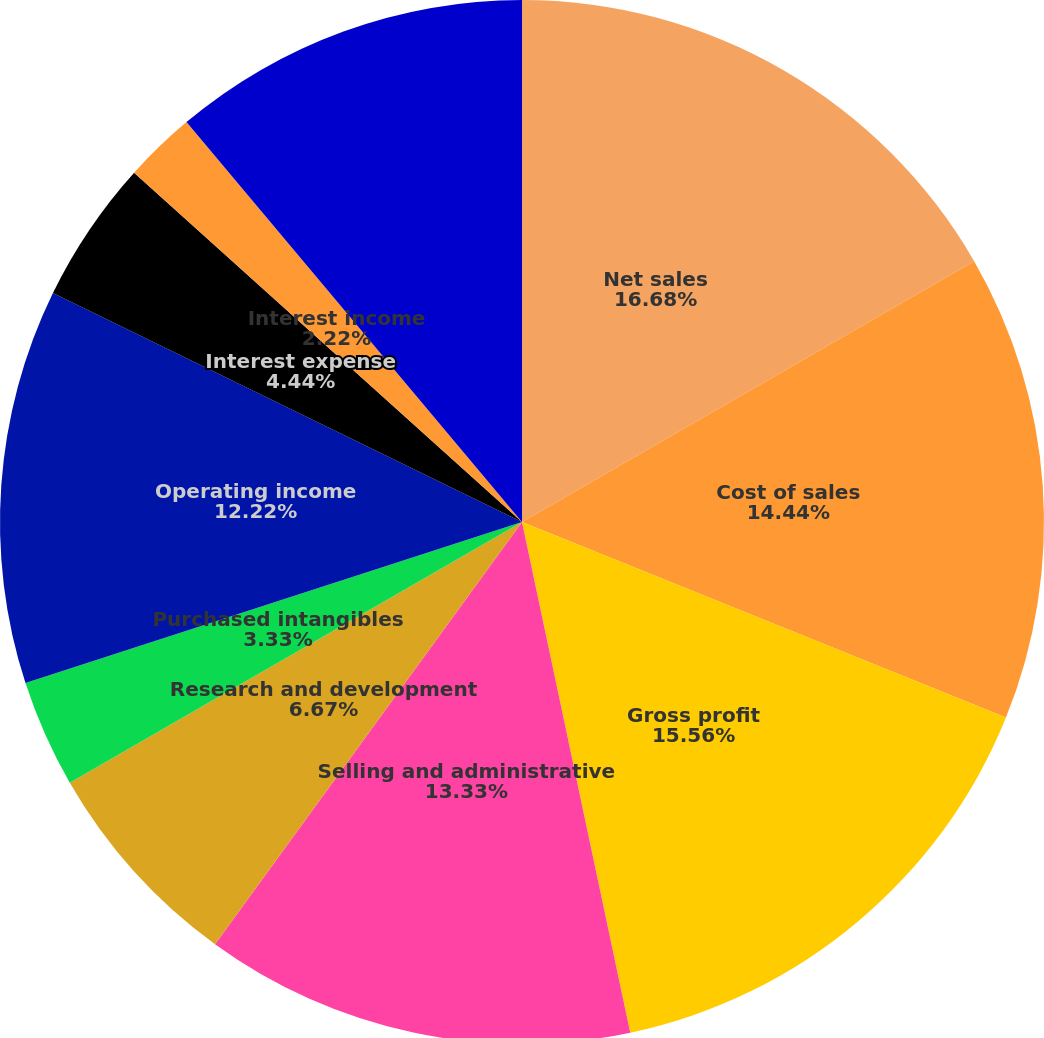Convert chart to OTSL. <chart><loc_0><loc_0><loc_500><loc_500><pie_chart><fcel>Net sales<fcel>Cost of sales<fcel>Gross profit<fcel>Selling and administrative<fcel>Research and development<fcel>Purchased intangibles<fcel>Operating income<fcel>Interest expense<fcel>Interest income<fcel>Income from operations before<nl><fcel>16.67%<fcel>14.44%<fcel>15.56%<fcel>13.33%<fcel>6.67%<fcel>3.33%<fcel>12.22%<fcel>4.44%<fcel>2.22%<fcel>11.11%<nl></chart> 